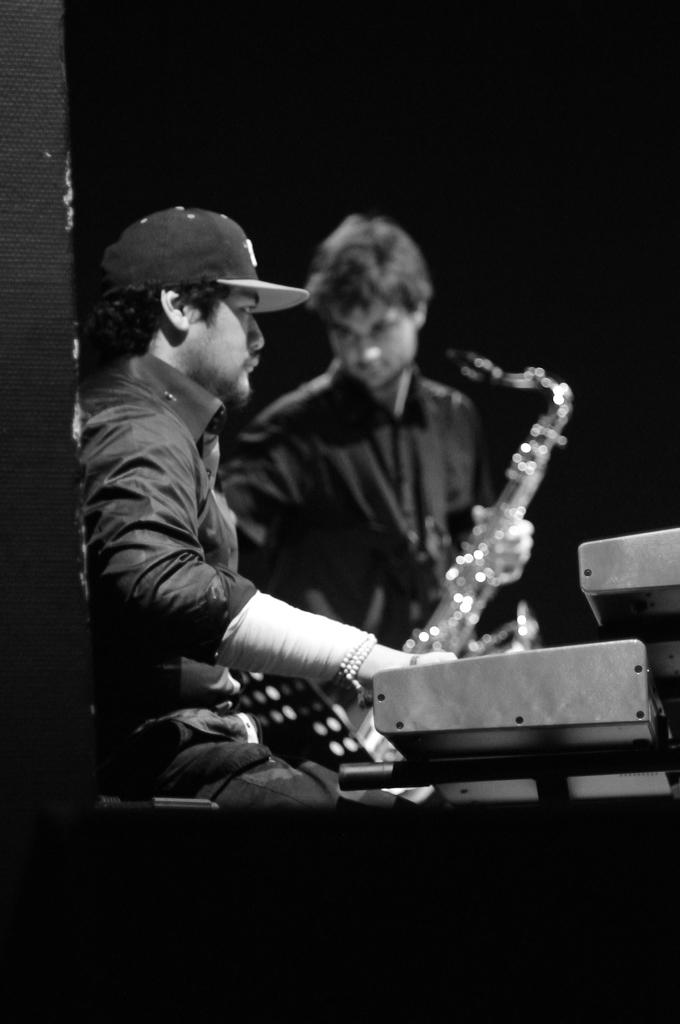What is the color scheme of the image? The image is black and white. How many people are in the image? There are two men in the image. What are the men doing in the image? The men are playing music instruments. What can be seen behind the men in the image? The background of the men is dark. Who is the owner of the bead in the image? There is no bead present in the image. What time of day is depicted in the image? The image is black and white, and there is no indication of the time of day. 